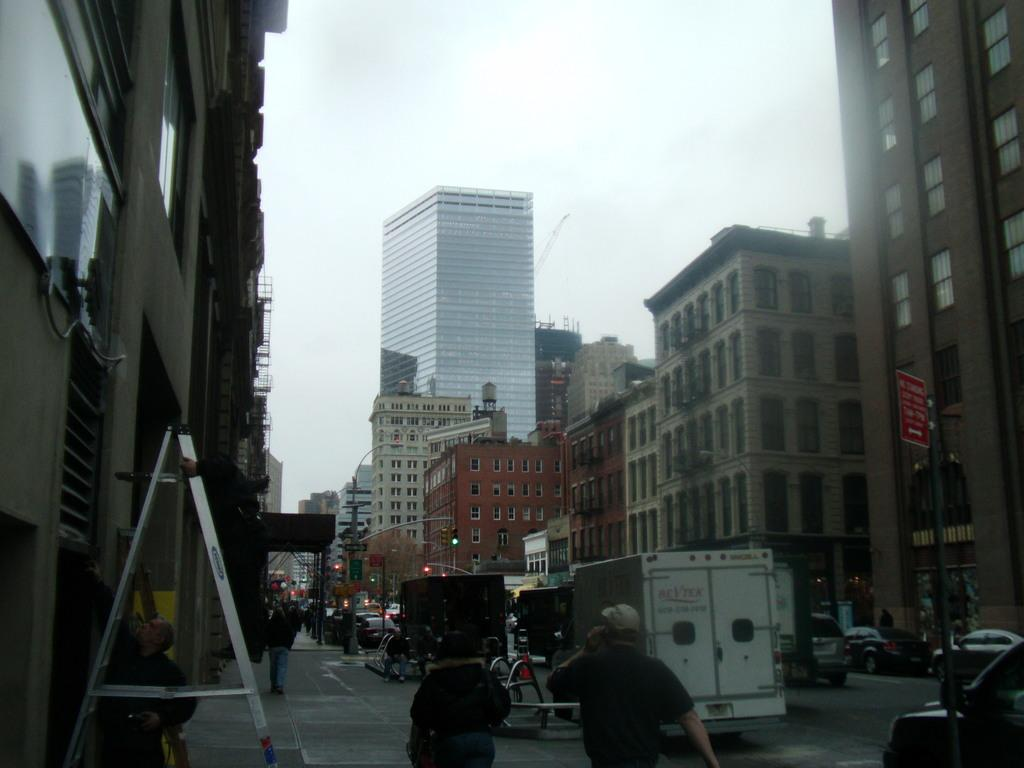What type of structures can be seen in the image? There are buildings in the image. What are some other objects visible on the street? There are street poles and traffic lights in the image. What mode of transportation can be seen in the image? There are motor vehicles in the image. Are there any people present in the image? Yes, there are persons on the road in the image. What type of receipt can be seen in the image? There is no receipt present in the image. What health-related information can be found in the image? The image does not contain any health-related information. 